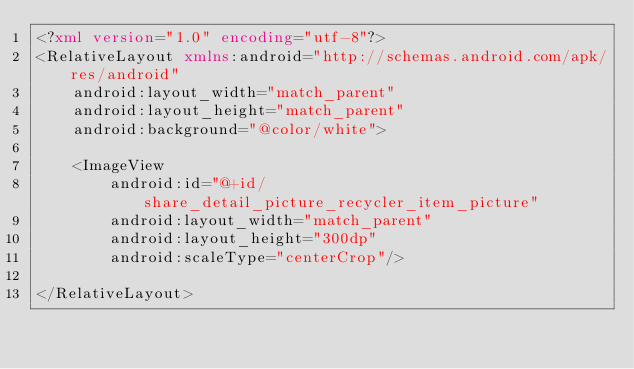<code> <loc_0><loc_0><loc_500><loc_500><_XML_><?xml version="1.0" encoding="utf-8"?>
<RelativeLayout xmlns:android="http://schemas.android.com/apk/res/android"
    android:layout_width="match_parent"
    android:layout_height="match_parent"
    android:background="@color/white">

    <ImageView
        android:id="@+id/share_detail_picture_recycler_item_picture"
        android:layout_width="match_parent"
        android:layout_height="300dp"
        android:scaleType="centerCrop"/>

</RelativeLayout></code> 